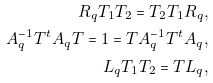Convert formula to latex. <formula><loc_0><loc_0><loc_500><loc_500>R _ { q } T _ { 1 } T _ { 2 } = T _ { 2 } T _ { 1 } R _ { q } , \\ A _ { q } ^ { - 1 } T ^ { t } A _ { q } T = 1 = T A _ { q } ^ { - 1 } T ^ { t } A _ { q } , \\ L _ { q } T _ { 1 } T _ { 2 } = T L _ { q } ,</formula> 